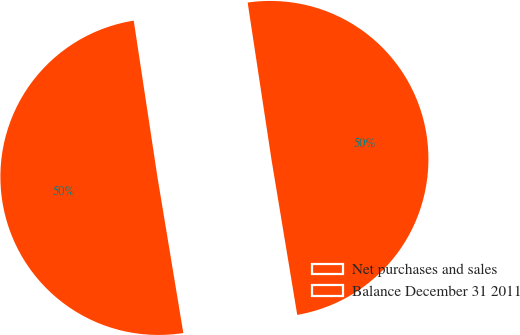<chart> <loc_0><loc_0><loc_500><loc_500><pie_chart><fcel>Net purchases and sales<fcel>Balance December 31 2011<nl><fcel>49.78%<fcel>50.22%<nl></chart> 